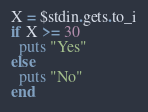<code> <loc_0><loc_0><loc_500><loc_500><_Ruby_>X = $stdin.gets.to_i
if X >= 30
  puts "Yes"
else
  puts "No"
end
</code> 